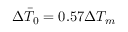Convert formula to latex. <formula><loc_0><loc_0><loc_500><loc_500>\Delta \bar { T } _ { 0 } = 0 . 5 7 \Delta T _ { m }</formula> 